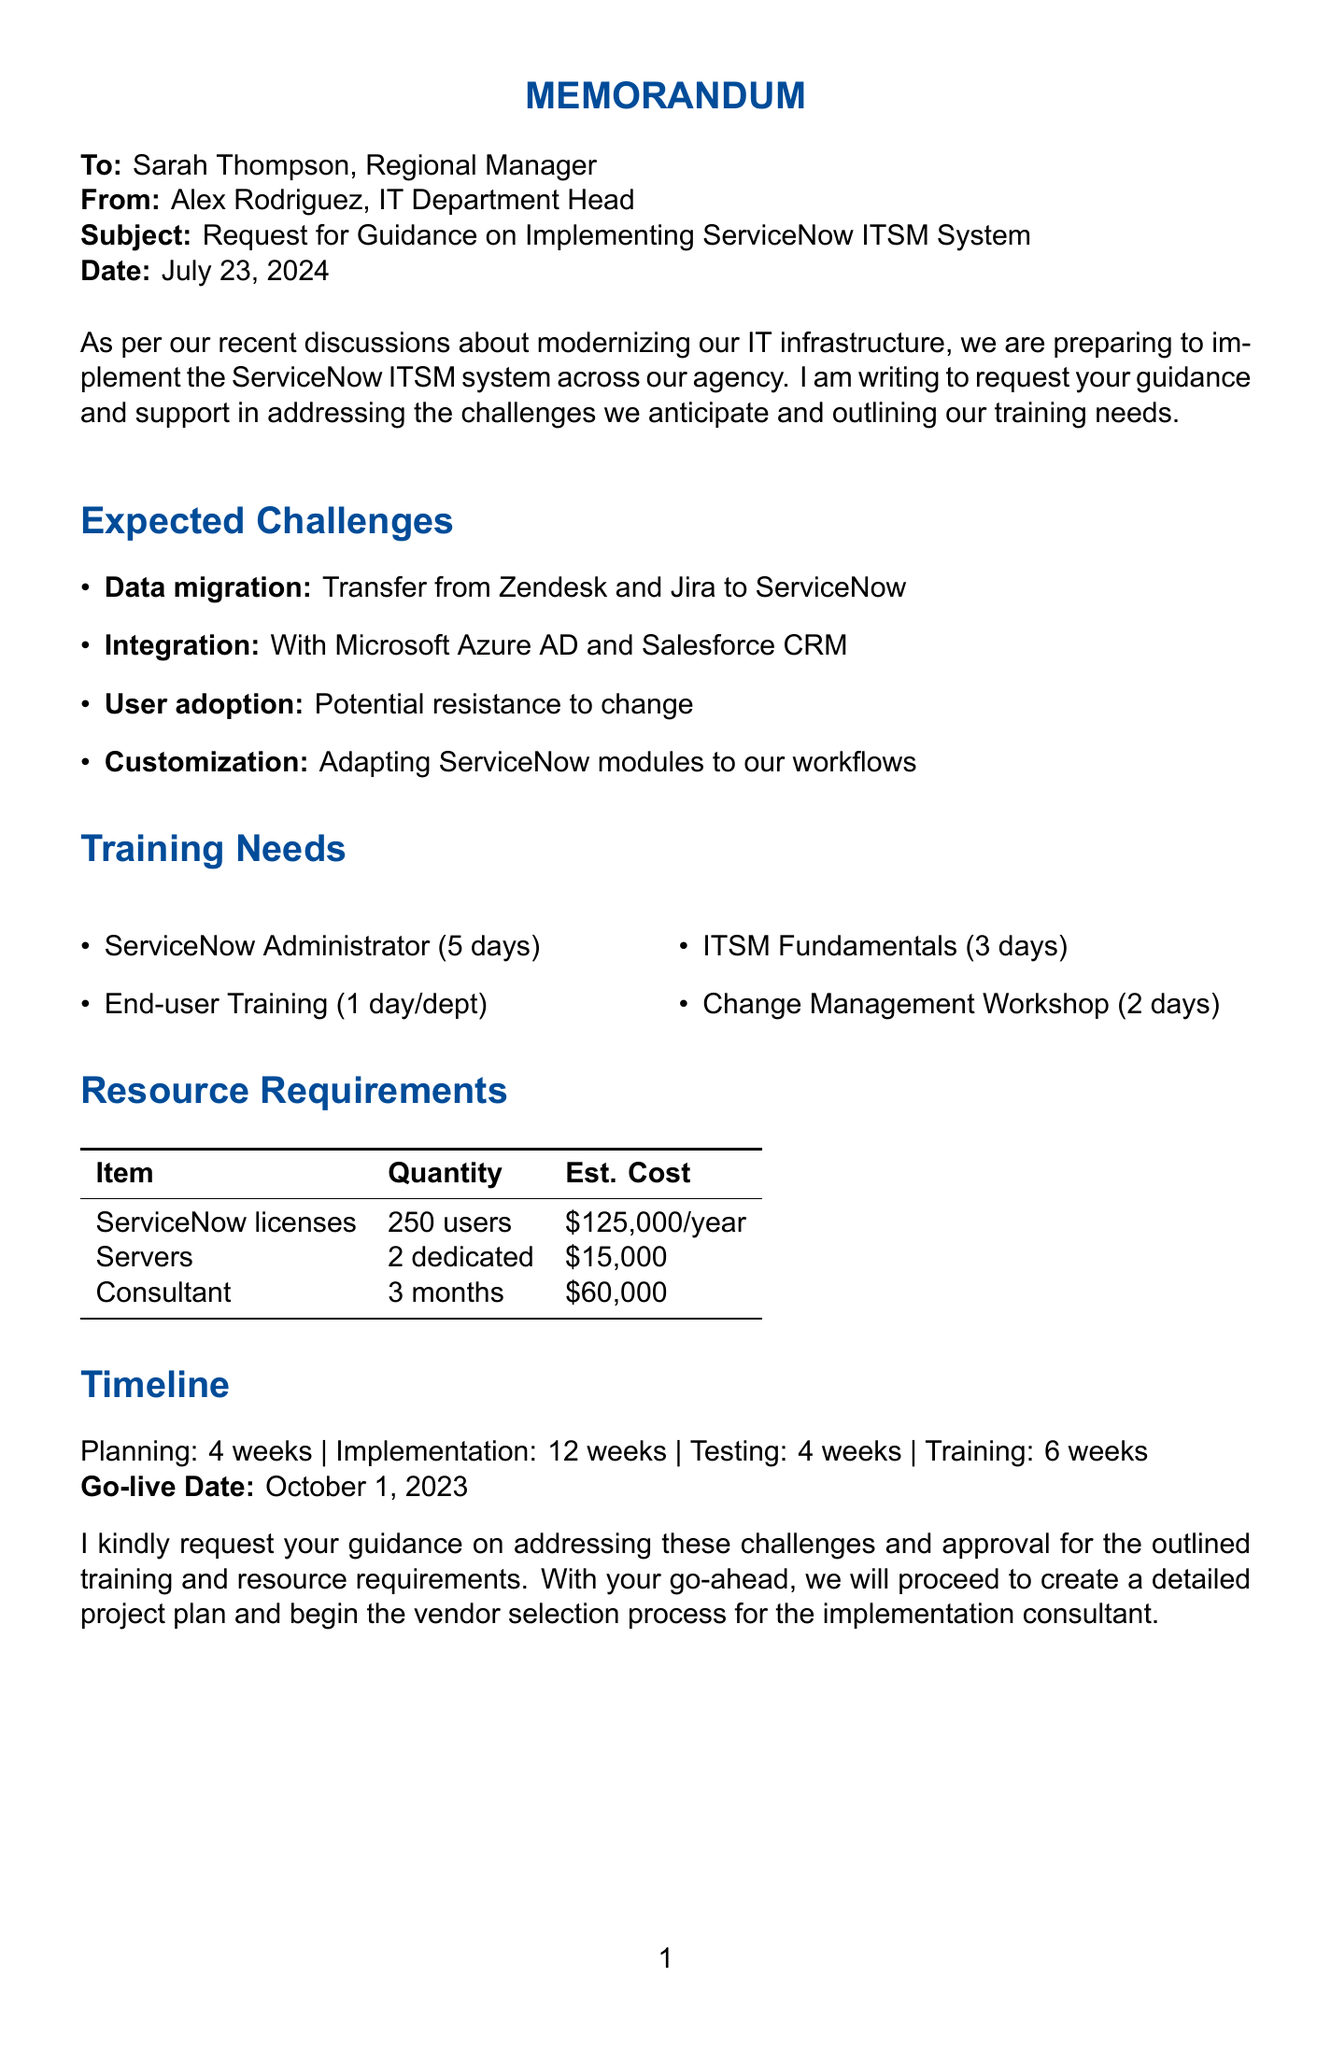What is the subject of the memo? The subject of the memo is explicitly stated at the top as a request regarding the new software system implementation.
Answer: Request for Guidance on Implementing ServiceNow ITSM System Who is the sender of the memo? The sender information is located at the top of the memo, indicating the person who is requesting guidance.
Answer: Alex Rodriguez What is the expected duration of the ServiceNow Administrator Training? The duration for this specific training can be found in the training needs section of the document.
Answer: 5 days What is the go-live date for the ServiceNow ITSM system? The go-live date is explicitly mentioned towards the end of the timeline section.
Answer: October 1, 2023 How many dedicated servers are needed? The resource requirements section provides the quantity of servers needed for the implementation.
Answer: 2 dedicated servers What is one anticipated challenge related to user interaction with the new software? The document lists potential challenges in user adoption, particularly regarding the staff's comfort with current systems.
Answer: Resistance to change What training type requires the participation of department heads? The training needs section specifies training that targets leaders within the organization, indicating its audience.
Answer: Change Management Workshop What is the estimated cost for the ServiceNow ITSM licenses? This information is found in the resource requirements section detailing the financial aspect of the license procurement.
Answer: $125,000 annually 